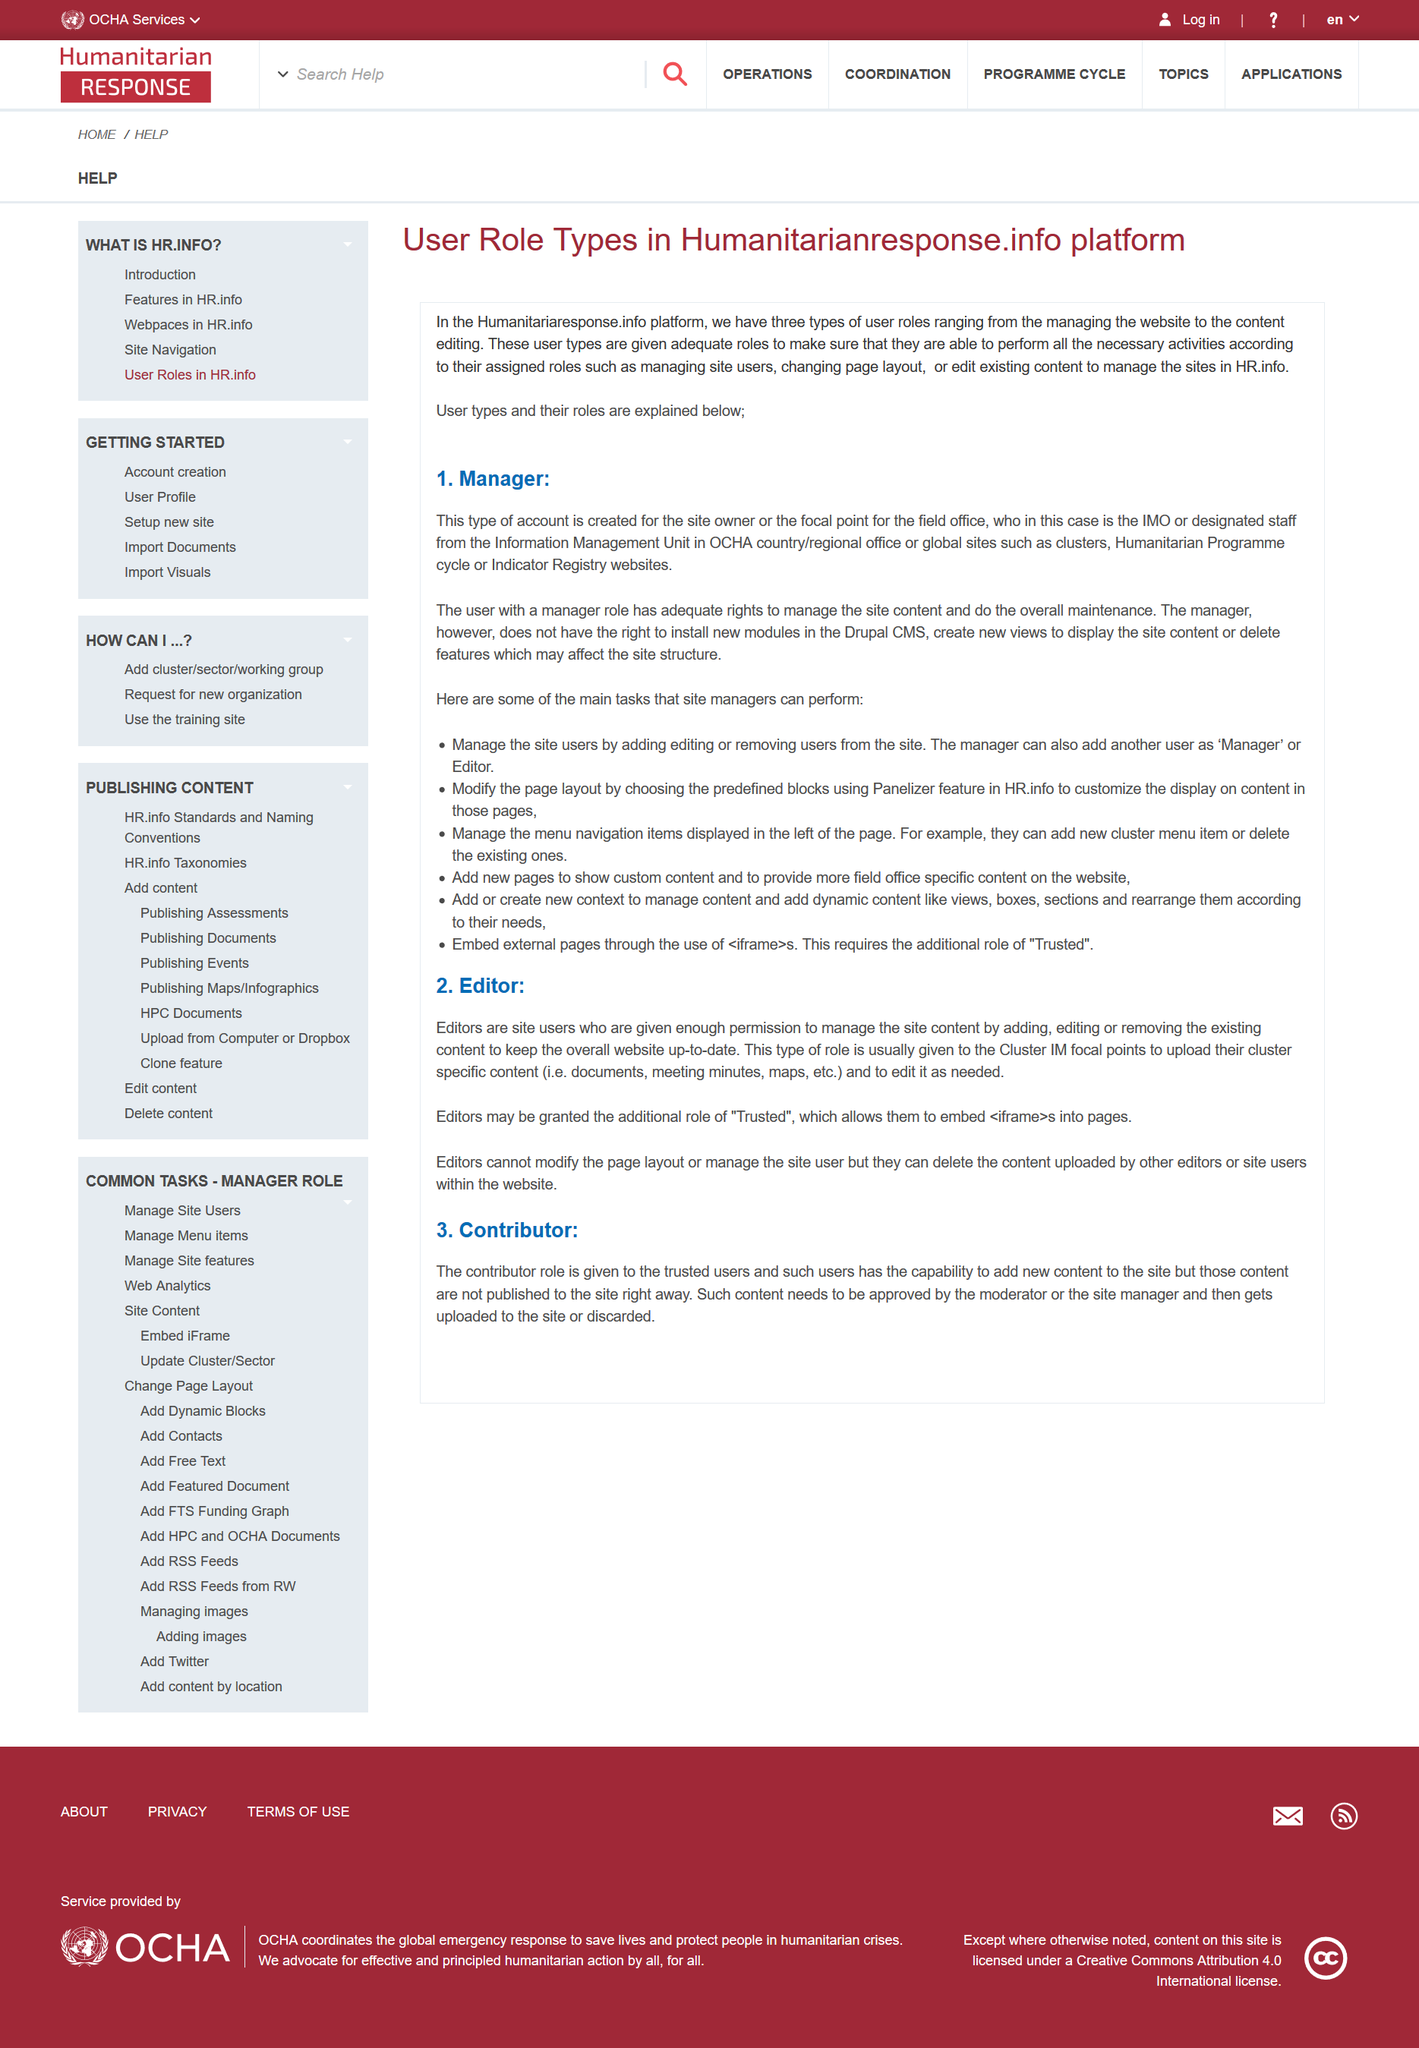Specify some key components in this picture. The two main roles depicted are Editor and Contributor. Editors may be granted the "trusted" role, which provides additional permissions beyond those granted to regular users. A manager account is created for the site owner, and a standard account is created for the members. Contributors have the capability to add new content to the site. It is not permissible for the manager to add new modules to the Drupal CMS. 